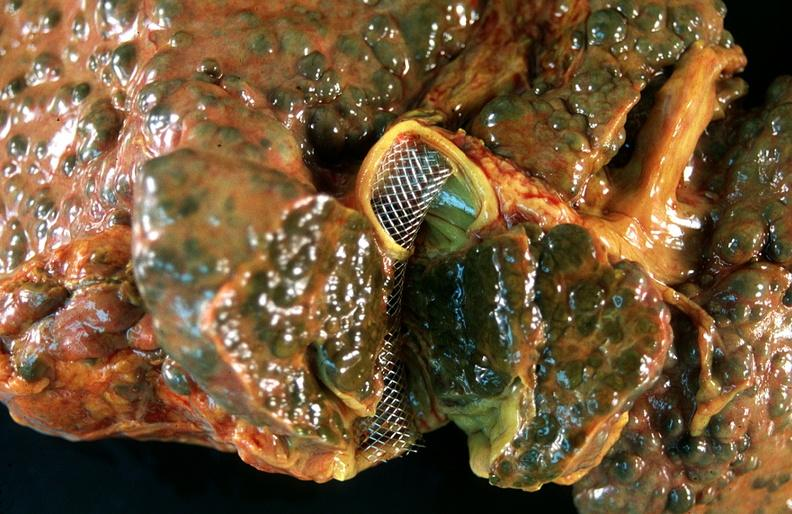does this image show liver, macronodular cirrhosis, hcv - transjugular intrahepatic portocaval shunt tips?
Answer the question using a single word or phrase. Yes 